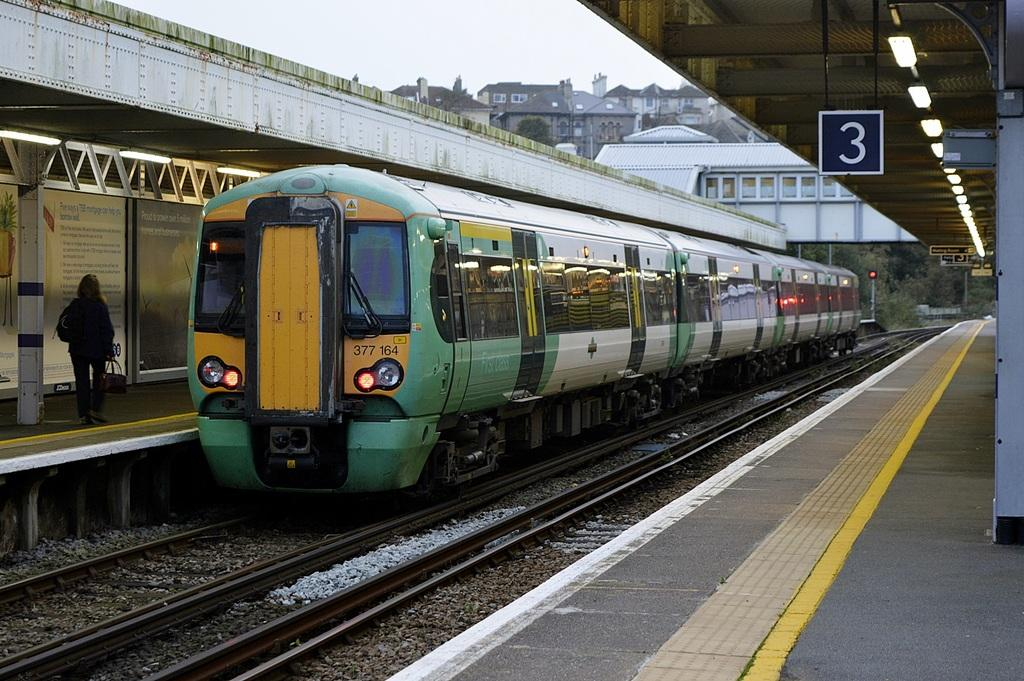<image>
Present a compact description of the photo's key features. the number 3 hovers over the train that is near 